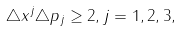<formula> <loc_0><loc_0><loc_500><loc_500>\triangle x ^ { j } \triangle p _ { j } \geq { 2 } , j = 1 , 2 , 3 ,</formula> 